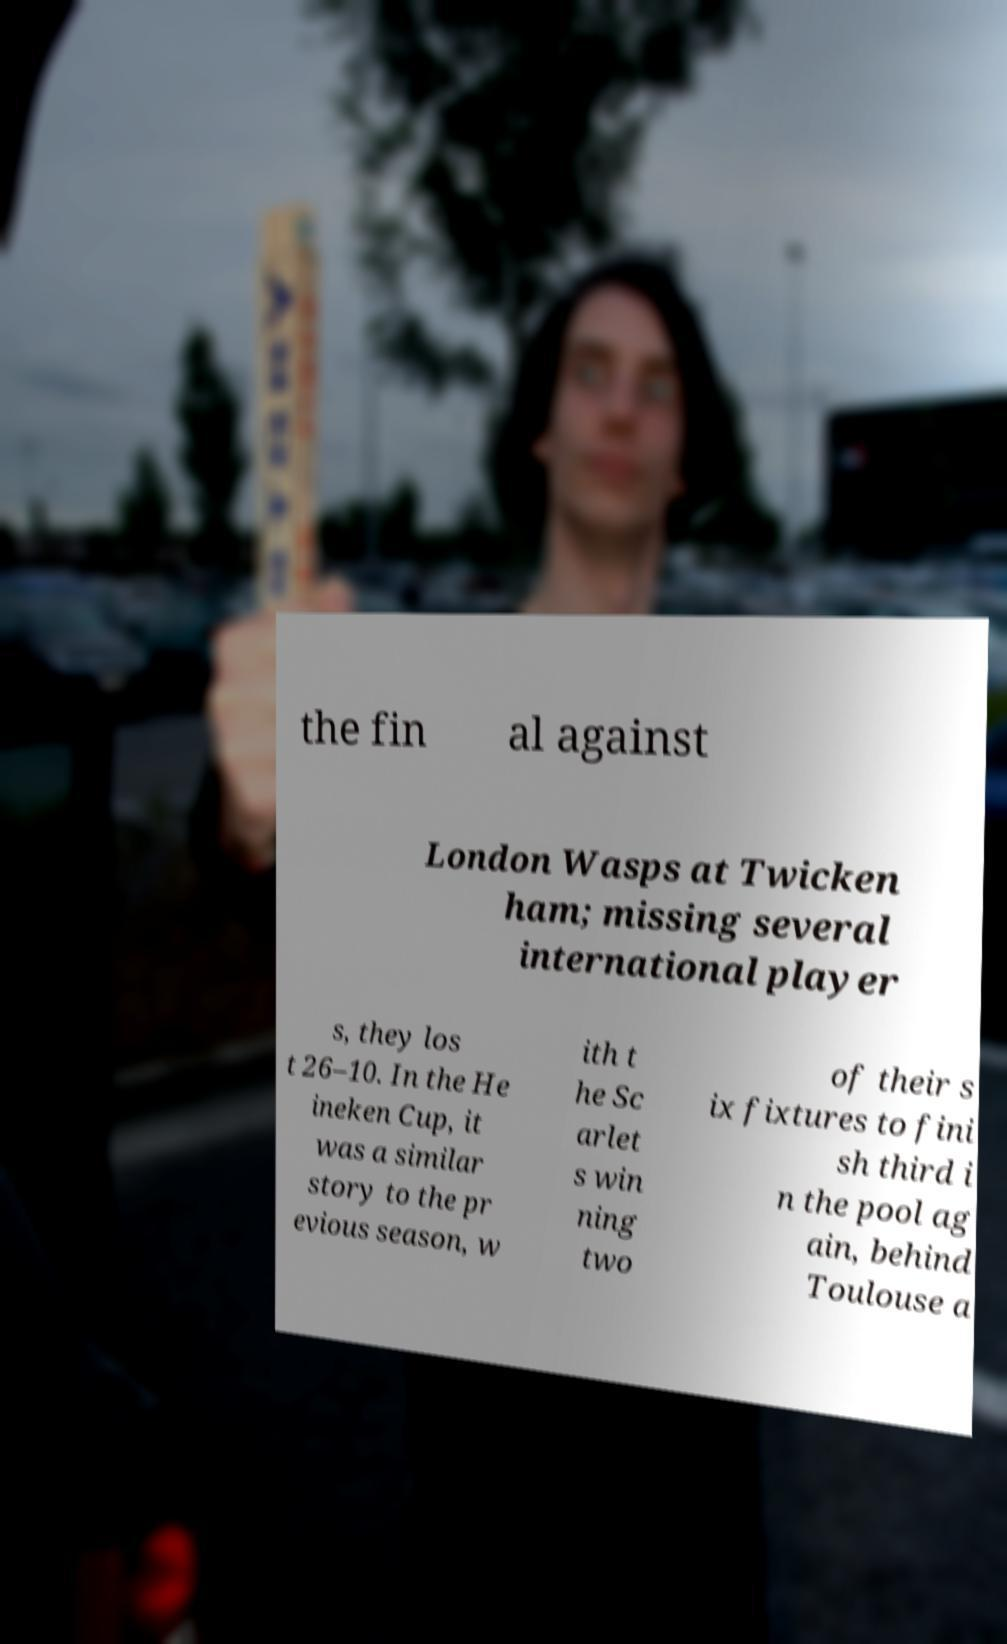For documentation purposes, I need the text within this image transcribed. Could you provide that? the fin al against London Wasps at Twicken ham; missing several international player s, they los t 26–10. In the He ineken Cup, it was a similar story to the pr evious season, w ith t he Sc arlet s win ning two of their s ix fixtures to fini sh third i n the pool ag ain, behind Toulouse a 